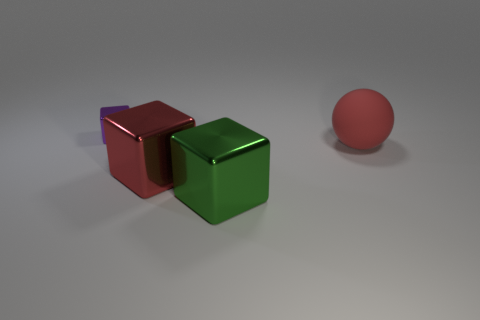Subtract all purple blocks. How many blocks are left? 2 Subtract all large metallic blocks. How many blocks are left? 1 Subtract 0 green cylinders. How many objects are left? 4 Subtract all cubes. How many objects are left? 1 Subtract 1 blocks. How many blocks are left? 2 Subtract all yellow balls. Subtract all purple blocks. How many balls are left? 1 Subtract all red cubes. How many blue spheres are left? 0 Subtract all small purple matte objects. Subtract all large green metal things. How many objects are left? 3 Add 3 big red shiny cubes. How many big red shiny cubes are left? 4 Add 2 small brown matte cubes. How many small brown matte cubes exist? 2 